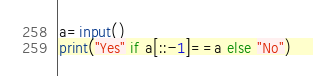Convert code to text. <code><loc_0><loc_0><loc_500><loc_500><_Python_>a=input()
print("Yes" if a[::-1]==a else "No")</code> 